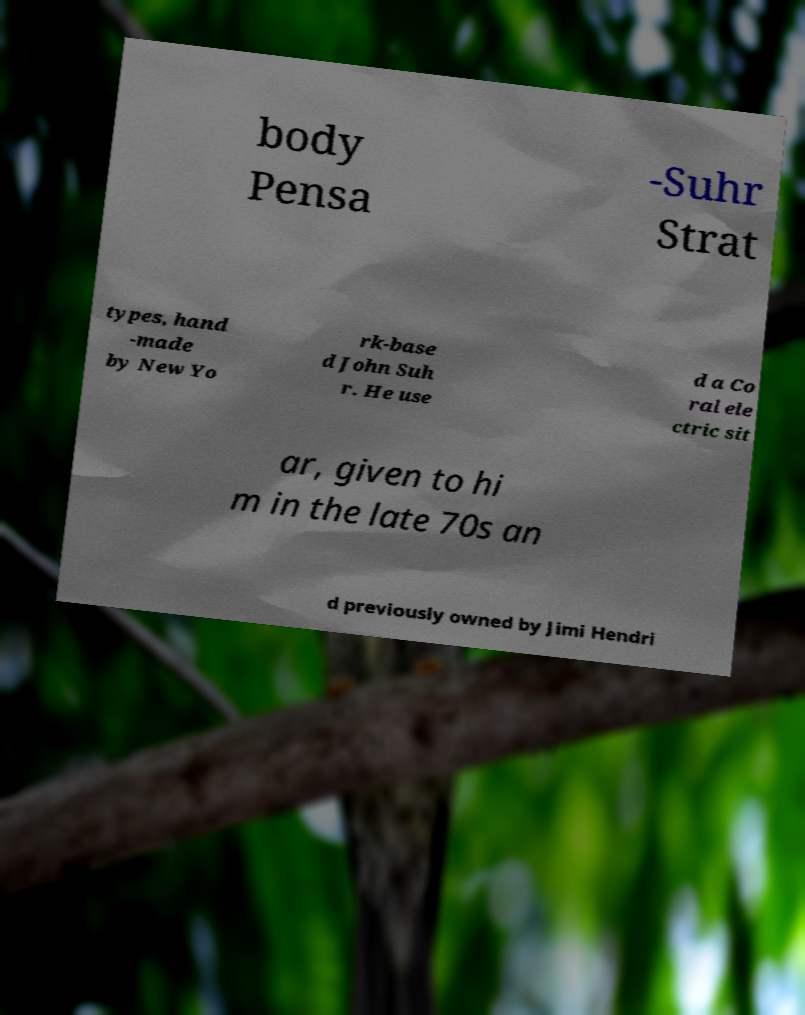Could you extract and type out the text from this image? body Pensa -Suhr Strat types, hand -made by New Yo rk-base d John Suh r. He use d a Co ral ele ctric sit ar, given to hi m in the late 70s an d previously owned by Jimi Hendri 